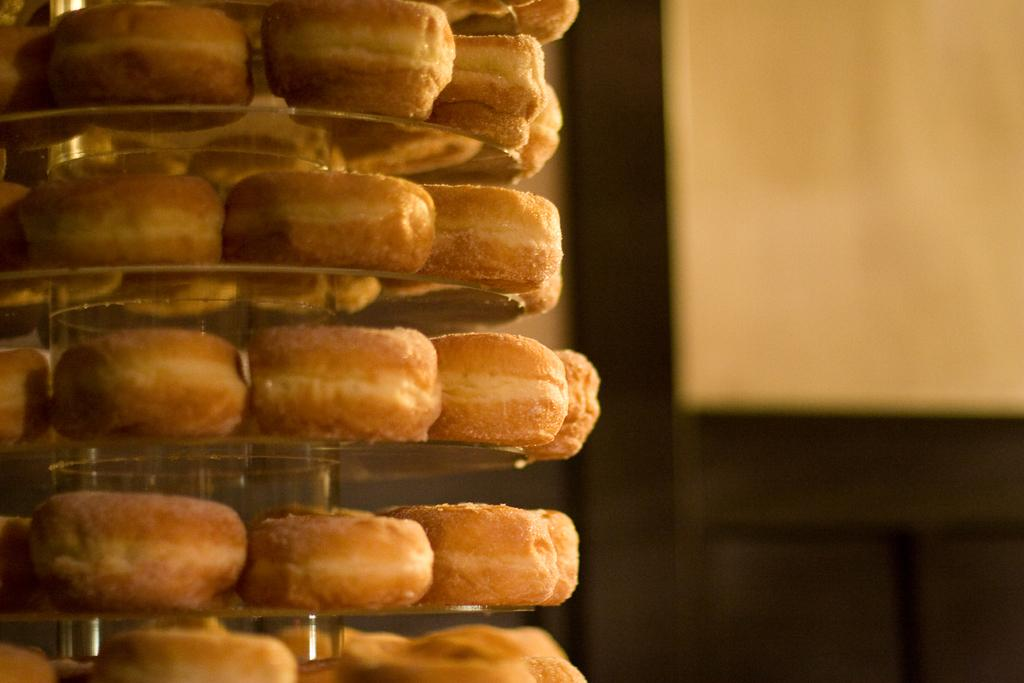What type of food is arranged on the shelves in the image? There are biscuits arranged on circular shelves in the image. What can be seen in the background of the image? There is a door in the background of the image. Where is the door located in relation to other objects in the image? The door is near a wall in the image. How many legs does the man have in the image? There is no man present in the image, so it is not possible to determine the number of legs. 